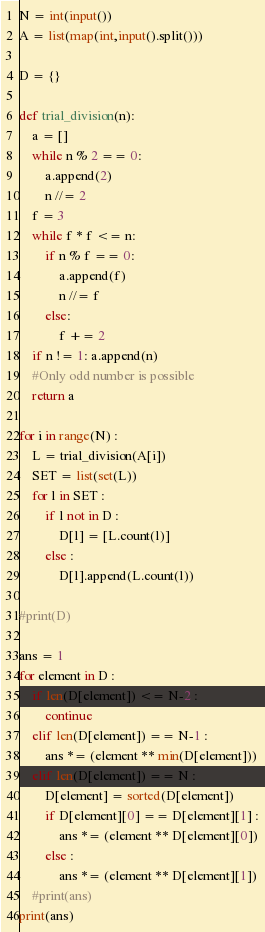<code> <loc_0><loc_0><loc_500><loc_500><_Python_>N = int(input())
A = list(map(int,input().split()))

D = {}

def trial_division(n):
    a = []  
    while n % 2 == 0:
        a.append(2)
        n //= 2
    f = 3
    while f * f <= n:
        if n % f == 0:
            a.append(f)
            n //= f
        else:
            f += 2   
    if n != 1: a.append(n)
    #Only odd number is possible
    return a

for i in range(N) :
    L = trial_division(A[i])
    SET = list(set(L))
    for l in SET :
        if l not in D :
            D[l] = [L.count(l)]
        else :
            D[l].append(L.count(l))

#print(D)

ans = 1
for element in D :
    if len(D[element]) <= N-2 :
        continue
    elif len(D[element]) == N-1 :
        ans *= (element ** min(D[element]))
    elif len(D[element]) == N :
        D[element] = sorted(D[element])
        if D[element][0] == D[element][1] :
            ans *= (element ** D[element][0])
        else :
            ans *= (element ** D[element][1])
    #print(ans)
print(ans)</code> 